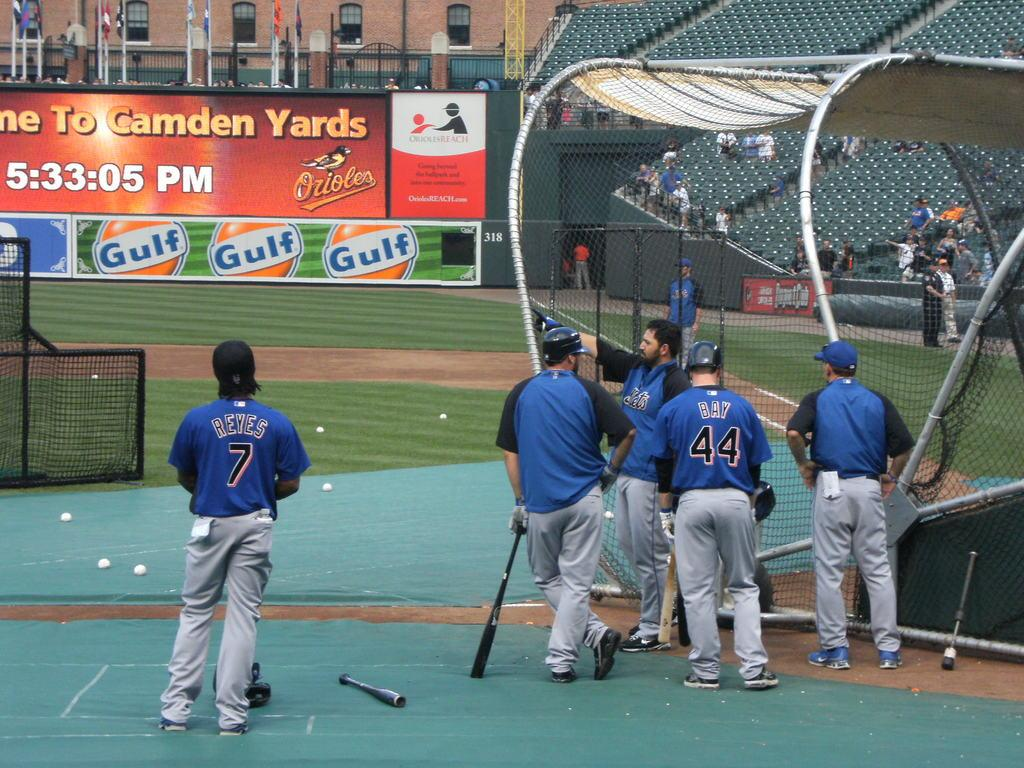<image>
Write a terse but informative summary of the picture. A baseball team is standing by the batting catch in a stadium with ads for Gulf. 